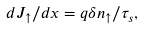<formula> <loc_0><loc_0><loc_500><loc_500>d J _ { \uparrow } / d x = q \delta n _ { \uparrow } / \tau _ { s } ,</formula> 